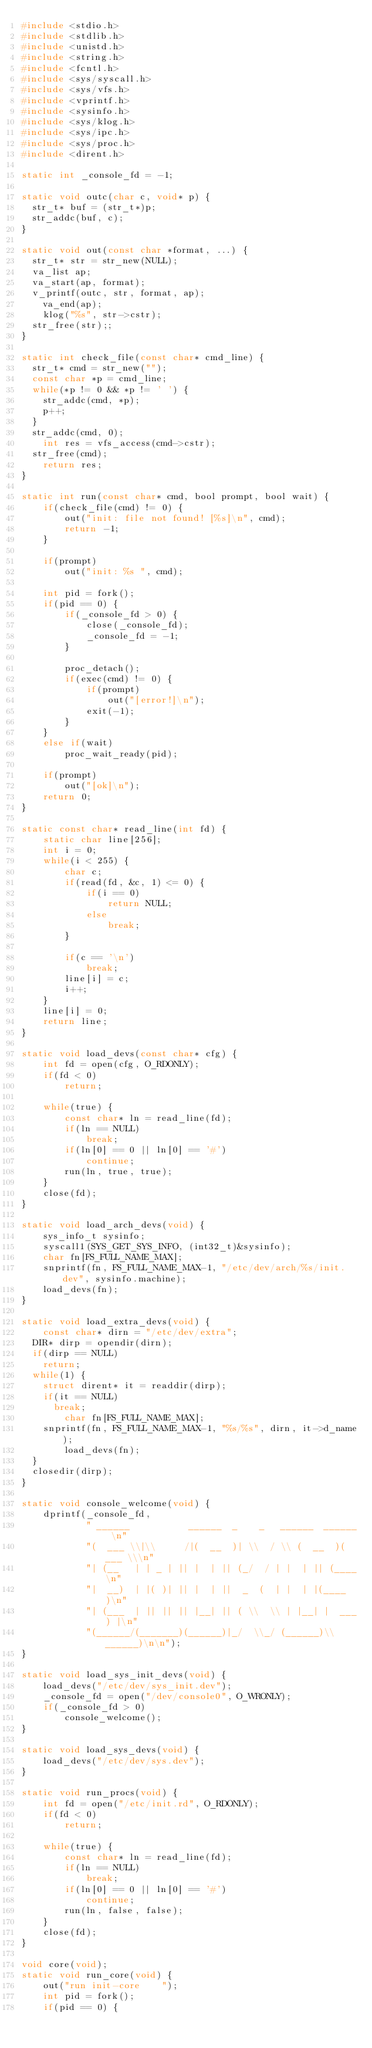Convert code to text. <code><loc_0><loc_0><loc_500><loc_500><_C_>#include <stdio.h>
#include <stdlib.h>
#include <unistd.h>
#include <string.h>
#include <fcntl.h>
#include <sys/syscall.h>
#include <sys/vfs.h>
#include <vprintf.h>
#include <sysinfo.h>
#include <sys/klog.h>
#include <sys/ipc.h>
#include <sys/proc.h>
#include <dirent.h>

static int _console_fd = -1;

static void outc(char c, void* p) {
  str_t* buf = (str_t*)p;
  str_addc(buf, c);
}

static void out(const char *format, ...) {
  str_t* str = str_new(NULL);
  va_list ap;
  va_start(ap, format);
  v_printf(outc, str, format, ap);
	va_end(ap);
	klog("%s", str->cstr);
  str_free(str);;
}

static int check_file(const char* cmd_line) {
  str_t* cmd = str_new("");
  const char *p = cmd_line;
  while(*p != 0 && *p != ' ') {
    str_addc(cmd, *p);
    p++;
  }
  str_addc(cmd, 0);
	int res = vfs_access(cmd->cstr);
  str_free(cmd);
	return res;
}

static int run(const char* cmd, bool prompt, bool wait) {
	if(check_file(cmd) != 0) {
		out("init: file not found! [%s]\n", cmd);
		return -1;
	}

	if(prompt)
		out("init: %s ", cmd);

	int pid = fork();
	if(pid == 0) {
		if(_console_fd > 0) {
			close(_console_fd);
			_console_fd = -1;
		}

		proc_detach();
		if(exec(cmd) != 0) {
			if(prompt)
				out("[error!]\n");
			exit(-1);
		}
	}
	else if(wait)
		proc_wait_ready(pid);

	if(prompt)
		out("[ok]\n");
	return 0;
}

static const char* read_line(int fd) {
	static char line[256];
	int i = 0;
	while(i < 255) {
		char c;
		if(read(fd, &c, 1) <= 0) {
			if(i == 0)
				return NULL;
			else
				break;
		}	

		if(c == '\n')
			break;
		line[i] = c;
		i++;
	}
	line[i] = 0;
	return line;
}

static void load_devs(const char* cfg) {
	int fd = open(cfg, O_RDONLY);
	if(fd < 0)
		return;

	while(true) {
		const char* ln = read_line(fd);
		if(ln == NULL)
			break;
		if(ln[0] == 0 || ln[0] == '#')
			continue;
		run(ln, true, true);
	}
	close(fd);
}

static void load_arch_devs(void) {
	sys_info_t sysinfo;
	syscall1(SYS_GET_SYS_INFO, (int32_t)&sysinfo);
	char fn[FS_FULL_NAME_MAX];
	snprintf(fn, FS_FULL_NAME_MAX-1, "/etc/dev/arch/%s/init.dev", sysinfo.machine);
	load_devs(fn);
}

static void load_extra_devs(void) {
	const char* dirn = "/etc/dev/extra";
  DIR* dirp = opendir(dirn);
  if(dirp == NULL)
    return;
  while(1) {
    struct dirent* it = readdir(dirp);
    if(it == NULL)
      break;
		char fn[FS_FULL_NAME_MAX];
    snprintf(fn, FS_FULL_NAME_MAX-1, "%s/%s", dirn, it->d_name);
		load_devs(fn);
  }
  closedir(dirp);
}

static void console_welcome(void) {
	dprintf(_console_fd,
			" ______           ______  _    _   ______  ______ \n"
			"(  ___ \\|\\     /|(  __  )| \\  / \\ (  __  )(  ___ \\\n"
			"| (__   | | _ | || |  | || (_/  / | |  | || (____\n"
			"|  __)  | |( )| || |  | ||  _  (  | |  | |(____  )\n"
			"| (___  | || || || |__| || ( \\  \\ | |__| |  ___) |\n"
			"(______/(_______)(______)|_/  \\_/ (______)\\______)\n\n");
}

static void load_sys_init_devs(void) {
	load_devs("/etc/dev/sys_init.dev");
	_console_fd = open("/dev/console0", O_WRONLY);
	if(_console_fd > 0) 
		console_welcome();
}

static void load_sys_devs(void) {
	load_devs("/etc/dev/sys.dev");
}

static void run_procs(void) {
	int fd = open("/etc/init.rd", O_RDONLY);
	if(fd < 0)
		return;

	while(true) {
		const char* ln = read_line(fd);
		if(ln == NULL)
			break;
		if(ln[0] == 0 || ln[0] == '#')
			continue;
		run(ln, false, false);
	}
	close(fd);
}

void core(void);
static void run_core(void) {
	out("run init-core    ");
	int pid = fork();
	if(pid == 0) {</code> 